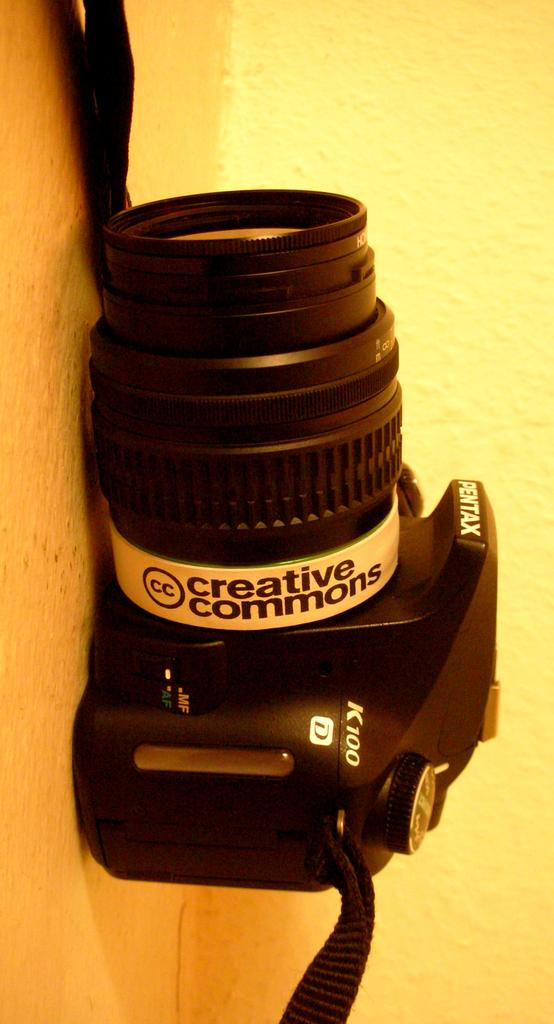What object is on the surface in the image? There is a camera on the surface. What can be seen on the camera? There is writing on the camera. What is visible in the background of the image? There is a wall in the background. What type of ink is being used to write on the camera in the image? There is no indication of the type of ink being used to write on the camera in the image. 